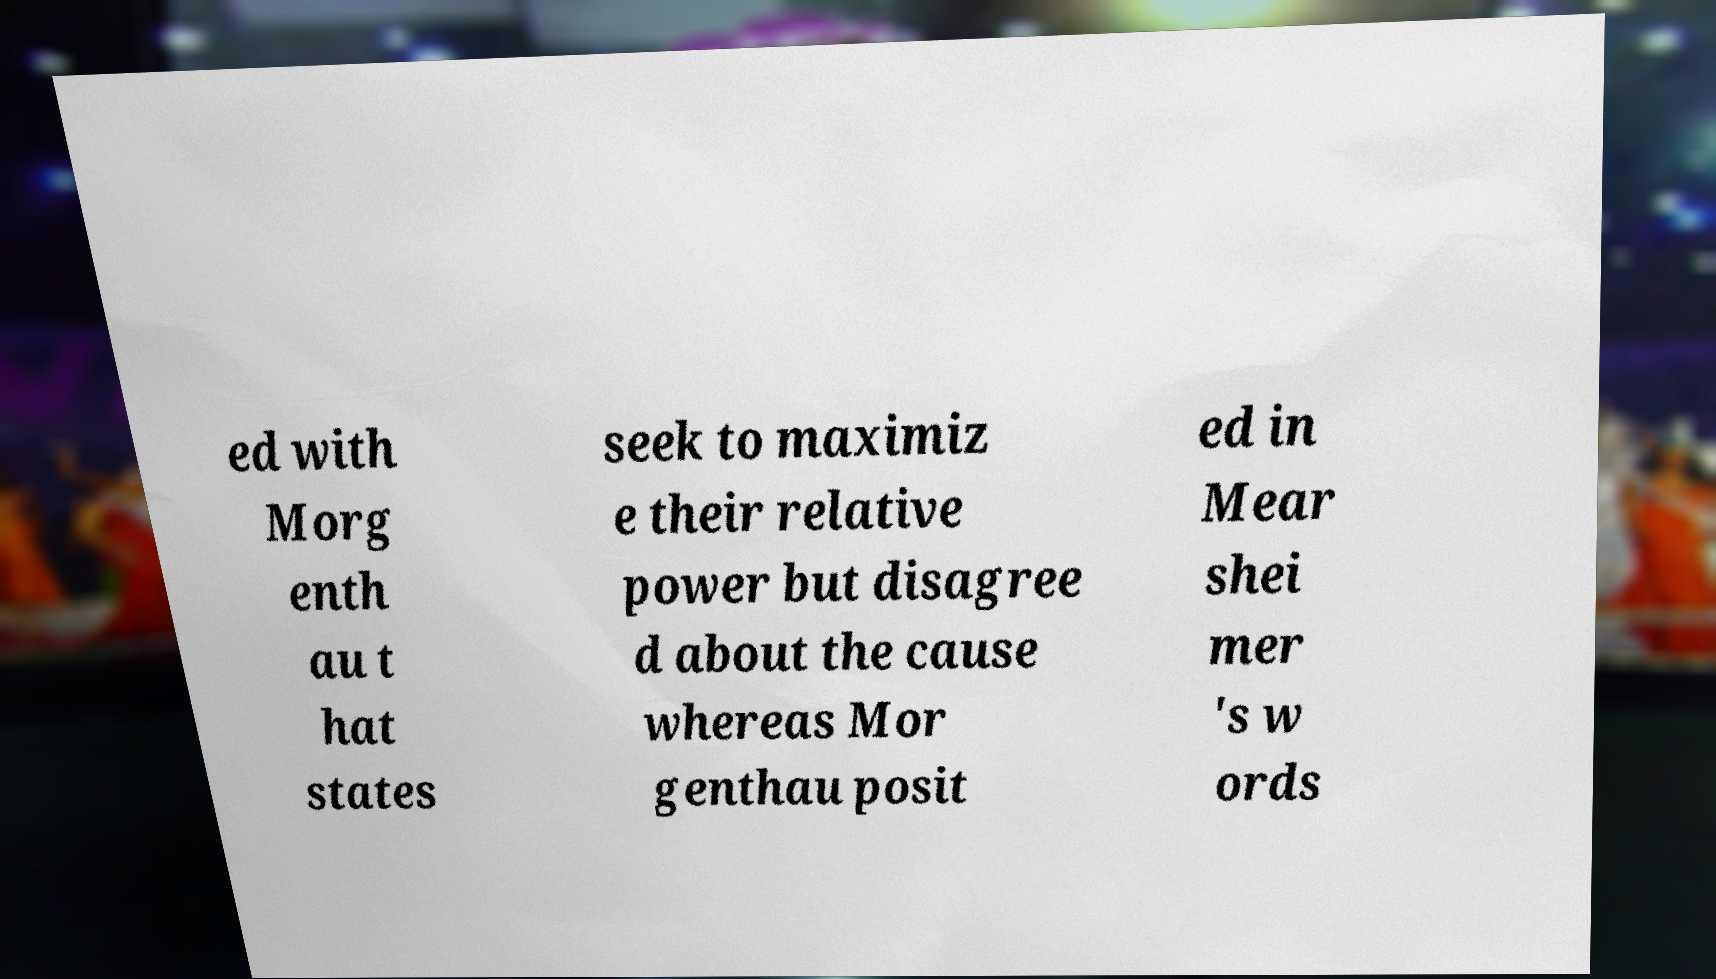Can you accurately transcribe the text from the provided image for me? ed with Morg enth au t hat states seek to maximiz e their relative power but disagree d about the cause whereas Mor genthau posit ed in Mear shei mer 's w ords 